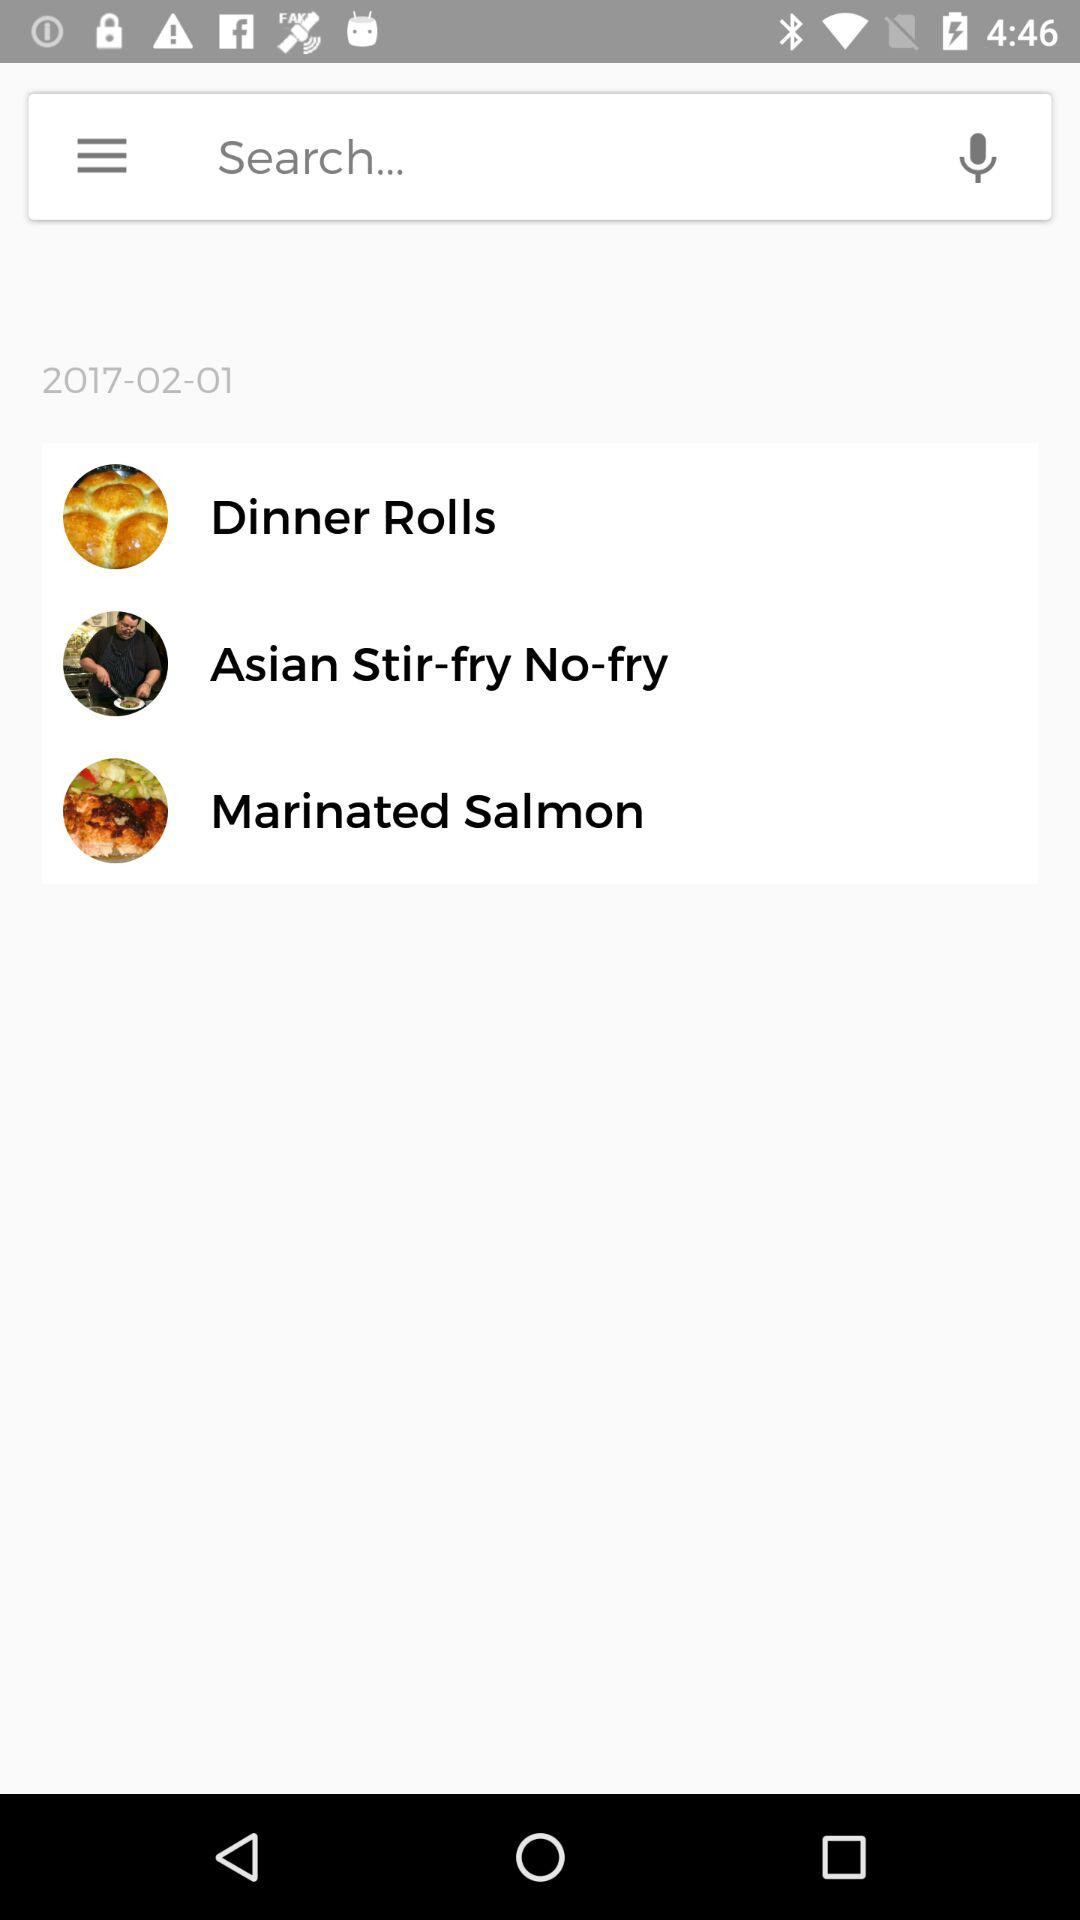Which date is shown on the screen? The shown date is February 1, 2017. 